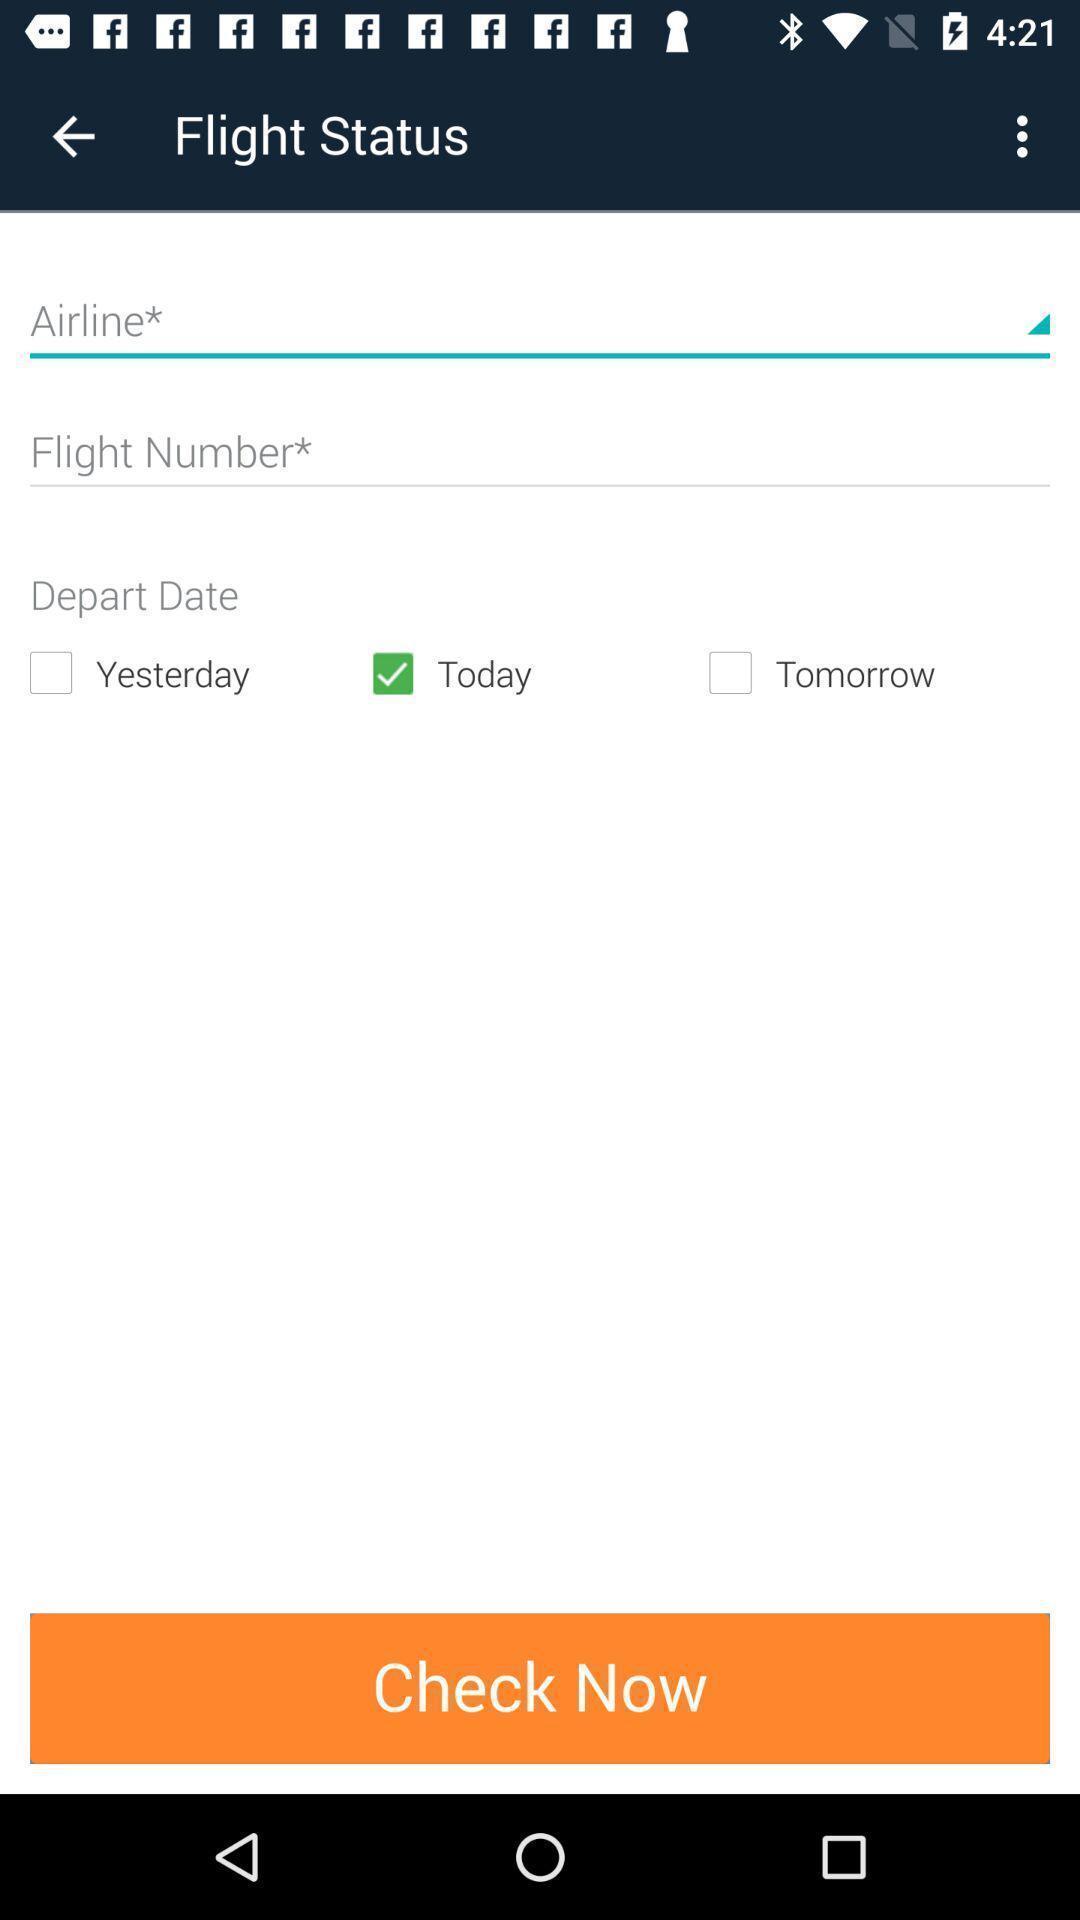Describe the visual elements of this screenshot. Screen shows multiple options in a travel application. 